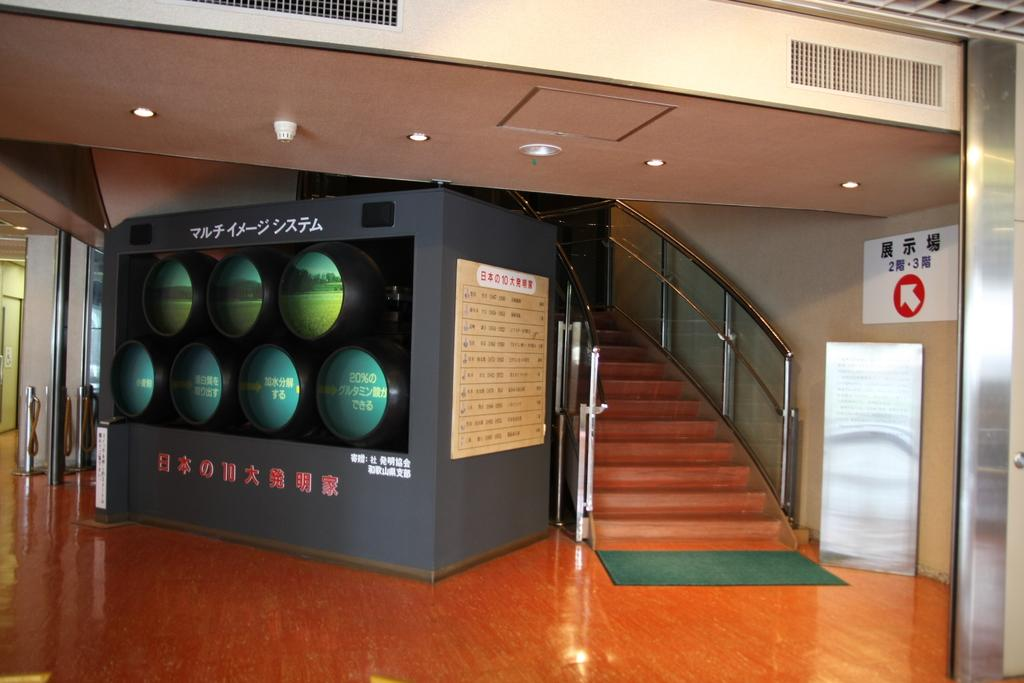What type of structure is present in the image? There is a staircase in the image. What can be seen on the wall in the image? There is a board on the wall in the image. What is located at the bottom of the staircase? There is a mat in the image. What is the purpose of the screen in the image? The purpose of the screen in the image is not specified, but it could be used for displaying information or as a partition. What type of discussion is taking place in the image? There is no discussion taking place in the image; it only features a staircase, a screen, a mat, and a board on the wall. Are there any police officers visible in the image? There are no police officers present in the image. Is there any smoke visible in the image? There is no smoke present in the image. 